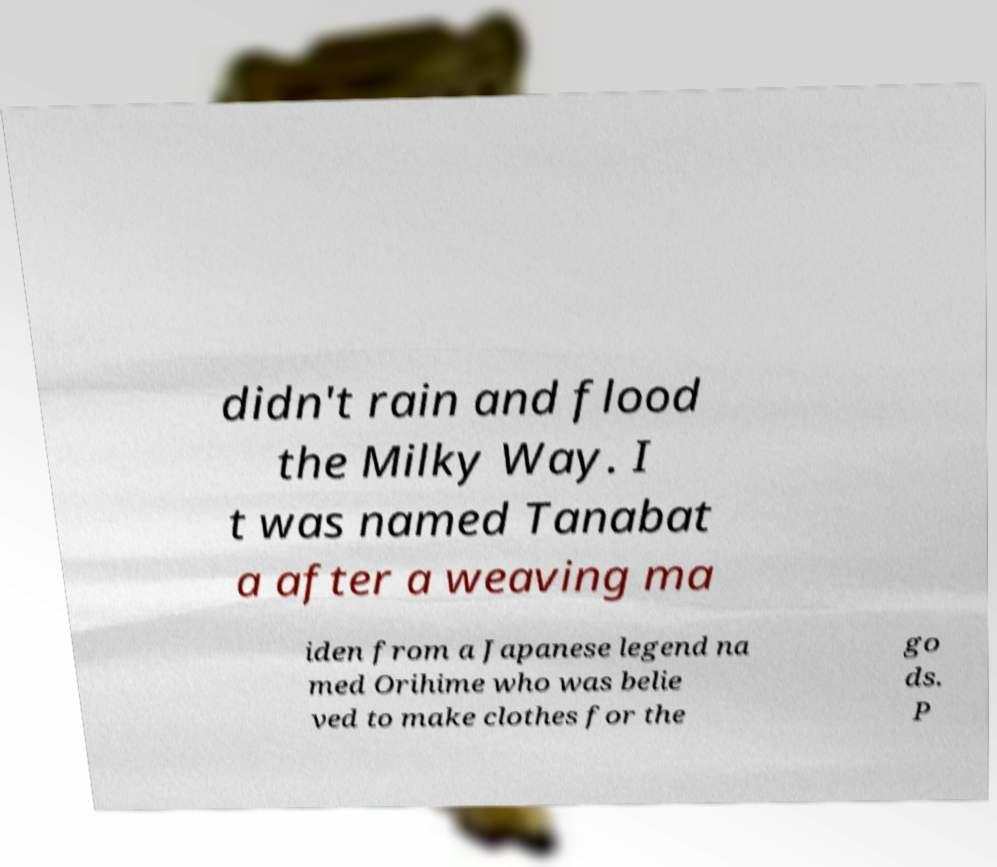Can you accurately transcribe the text from the provided image for me? didn't rain and flood the Milky Way. I t was named Tanabat a after a weaving ma iden from a Japanese legend na med Orihime who was belie ved to make clothes for the go ds. P 